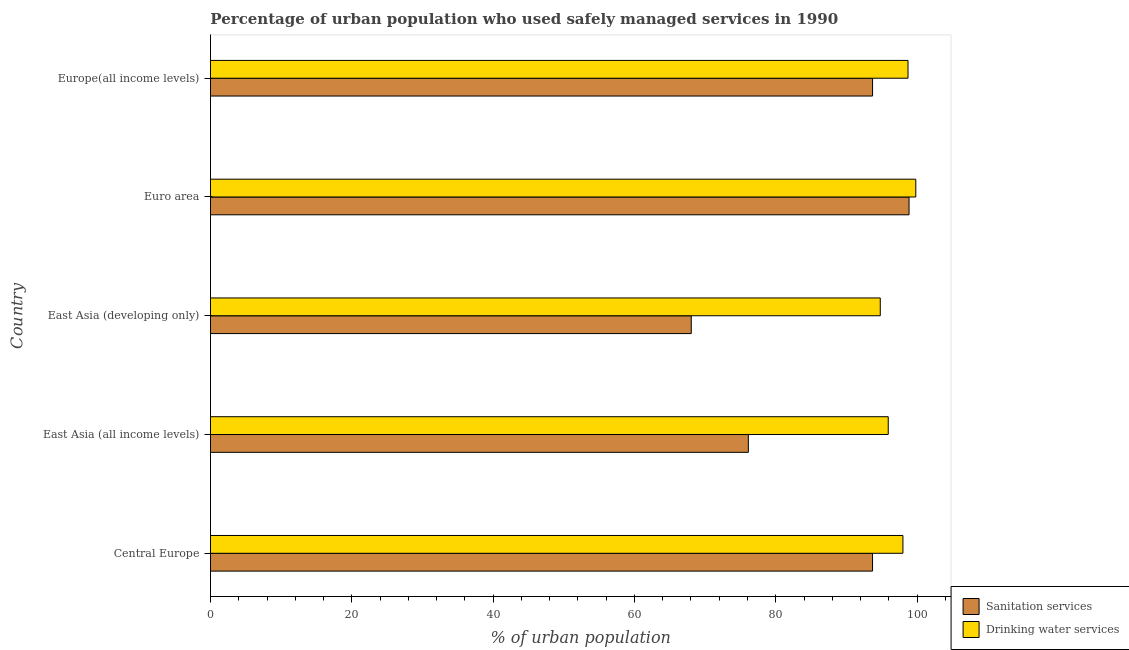Are the number of bars per tick equal to the number of legend labels?
Your answer should be very brief. Yes. Are the number of bars on each tick of the Y-axis equal?
Offer a terse response. Yes. What is the label of the 2nd group of bars from the top?
Offer a very short reply. Euro area. In how many cases, is the number of bars for a given country not equal to the number of legend labels?
Offer a very short reply. 0. What is the percentage of urban population who used drinking water services in Central Europe?
Offer a terse response. 97.99. Across all countries, what is the maximum percentage of urban population who used drinking water services?
Offer a terse response. 99.82. Across all countries, what is the minimum percentage of urban population who used drinking water services?
Offer a terse response. 94.79. In which country was the percentage of urban population who used sanitation services maximum?
Make the answer very short. Euro area. In which country was the percentage of urban population who used drinking water services minimum?
Your answer should be very brief. East Asia (developing only). What is the total percentage of urban population who used sanitation services in the graph?
Offer a terse response. 430.41. What is the difference between the percentage of urban population who used sanitation services in Euro area and that in Europe(all income levels)?
Your response must be concise. 5.16. What is the difference between the percentage of urban population who used sanitation services in East Asia (all income levels) and the percentage of urban population who used drinking water services in East Asia (developing only)?
Make the answer very short. -18.67. What is the average percentage of urban population who used drinking water services per country?
Your answer should be compact. 97.45. What is the difference between the percentage of urban population who used sanitation services and percentage of urban population who used drinking water services in East Asia (developing only)?
Provide a short and direct response. -26.75. What is the ratio of the percentage of urban population who used drinking water services in East Asia (developing only) to that in Europe(all income levels)?
Provide a succinct answer. 0.96. Is the difference between the percentage of urban population who used drinking water services in East Asia (all income levels) and East Asia (developing only) greater than the difference between the percentage of urban population who used sanitation services in East Asia (all income levels) and East Asia (developing only)?
Offer a terse response. No. What is the difference between the highest and the second highest percentage of urban population who used sanitation services?
Keep it short and to the point. 5.16. What is the difference between the highest and the lowest percentage of urban population who used drinking water services?
Provide a succinct answer. 5.03. Is the sum of the percentage of urban population who used sanitation services in Central Europe and Euro area greater than the maximum percentage of urban population who used drinking water services across all countries?
Give a very brief answer. Yes. What does the 2nd bar from the top in Euro area represents?
Your answer should be very brief. Sanitation services. What does the 2nd bar from the bottom in Euro area represents?
Make the answer very short. Drinking water services. How many countries are there in the graph?
Offer a very short reply. 5. What is the difference between two consecutive major ticks on the X-axis?
Make the answer very short. 20. Are the values on the major ticks of X-axis written in scientific E-notation?
Your response must be concise. No. Does the graph contain any zero values?
Offer a terse response. No. How many legend labels are there?
Ensure brevity in your answer.  2. How are the legend labels stacked?
Your answer should be very brief. Vertical. What is the title of the graph?
Keep it short and to the point. Percentage of urban population who used safely managed services in 1990. Does "Investment in Telecom" appear as one of the legend labels in the graph?
Provide a succinct answer. No. What is the label or title of the X-axis?
Your answer should be very brief. % of urban population. What is the % of urban population of Sanitation services in Central Europe?
Give a very brief answer. 93.69. What is the % of urban population of Drinking water services in Central Europe?
Your response must be concise. 97.99. What is the % of urban population of Sanitation services in East Asia (all income levels)?
Your answer should be very brief. 76.12. What is the % of urban population of Drinking water services in East Asia (all income levels)?
Offer a terse response. 95.92. What is the % of urban population in Sanitation services in East Asia (developing only)?
Make the answer very short. 68.04. What is the % of urban population of Drinking water services in East Asia (developing only)?
Ensure brevity in your answer.  94.79. What is the % of urban population in Sanitation services in Euro area?
Make the answer very short. 98.86. What is the % of urban population of Drinking water services in Euro area?
Make the answer very short. 99.82. What is the % of urban population of Sanitation services in Europe(all income levels)?
Offer a terse response. 93.7. What is the % of urban population of Drinking water services in Europe(all income levels)?
Provide a succinct answer. 98.71. Across all countries, what is the maximum % of urban population in Sanitation services?
Offer a very short reply. 98.86. Across all countries, what is the maximum % of urban population in Drinking water services?
Your answer should be compact. 99.82. Across all countries, what is the minimum % of urban population in Sanitation services?
Make the answer very short. 68.04. Across all countries, what is the minimum % of urban population of Drinking water services?
Ensure brevity in your answer.  94.79. What is the total % of urban population in Sanitation services in the graph?
Your answer should be compact. 430.41. What is the total % of urban population in Drinking water services in the graph?
Ensure brevity in your answer.  487.23. What is the difference between the % of urban population in Sanitation services in Central Europe and that in East Asia (all income levels)?
Ensure brevity in your answer.  17.58. What is the difference between the % of urban population in Drinking water services in Central Europe and that in East Asia (all income levels)?
Provide a succinct answer. 2.08. What is the difference between the % of urban population in Sanitation services in Central Europe and that in East Asia (developing only)?
Ensure brevity in your answer.  25.65. What is the difference between the % of urban population in Drinking water services in Central Europe and that in East Asia (developing only)?
Ensure brevity in your answer.  3.21. What is the difference between the % of urban population of Sanitation services in Central Europe and that in Euro area?
Provide a succinct answer. -5.17. What is the difference between the % of urban population of Drinking water services in Central Europe and that in Euro area?
Provide a succinct answer. -1.82. What is the difference between the % of urban population in Sanitation services in Central Europe and that in Europe(all income levels)?
Provide a succinct answer. -0. What is the difference between the % of urban population in Drinking water services in Central Europe and that in Europe(all income levels)?
Offer a very short reply. -0.72. What is the difference between the % of urban population of Sanitation services in East Asia (all income levels) and that in East Asia (developing only)?
Provide a short and direct response. 8.08. What is the difference between the % of urban population of Drinking water services in East Asia (all income levels) and that in East Asia (developing only)?
Your answer should be very brief. 1.13. What is the difference between the % of urban population of Sanitation services in East Asia (all income levels) and that in Euro area?
Provide a succinct answer. -22.74. What is the difference between the % of urban population of Drinking water services in East Asia (all income levels) and that in Euro area?
Make the answer very short. -3.9. What is the difference between the % of urban population in Sanitation services in East Asia (all income levels) and that in Europe(all income levels)?
Provide a short and direct response. -17.58. What is the difference between the % of urban population in Drinking water services in East Asia (all income levels) and that in Europe(all income levels)?
Your answer should be compact. -2.8. What is the difference between the % of urban population in Sanitation services in East Asia (developing only) and that in Euro area?
Make the answer very short. -30.82. What is the difference between the % of urban population of Drinking water services in East Asia (developing only) and that in Euro area?
Offer a very short reply. -5.03. What is the difference between the % of urban population in Sanitation services in East Asia (developing only) and that in Europe(all income levels)?
Provide a short and direct response. -25.66. What is the difference between the % of urban population of Drinking water services in East Asia (developing only) and that in Europe(all income levels)?
Provide a succinct answer. -3.93. What is the difference between the % of urban population in Sanitation services in Euro area and that in Europe(all income levels)?
Keep it short and to the point. 5.16. What is the difference between the % of urban population of Drinking water services in Euro area and that in Europe(all income levels)?
Your answer should be compact. 1.1. What is the difference between the % of urban population in Sanitation services in Central Europe and the % of urban population in Drinking water services in East Asia (all income levels)?
Ensure brevity in your answer.  -2.22. What is the difference between the % of urban population in Sanitation services in Central Europe and the % of urban population in Drinking water services in East Asia (developing only)?
Your answer should be compact. -1.09. What is the difference between the % of urban population of Sanitation services in Central Europe and the % of urban population of Drinking water services in Euro area?
Offer a very short reply. -6.12. What is the difference between the % of urban population of Sanitation services in Central Europe and the % of urban population of Drinking water services in Europe(all income levels)?
Your answer should be very brief. -5.02. What is the difference between the % of urban population of Sanitation services in East Asia (all income levels) and the % of urban population of Drinking water services in East Asia (developing only)?
Ensure brevity in your answer.  -18.67. What is the difference between the % of urban population of Sanitation services in East Asia (all income levels) and the % of urban population of Drinking water services in Euro area?
Provide a short and direct response. -23.7. What is the difference between the % of urban population of Sanitation services in East Asia (all income levels) and the % of urban population of Drinking water services in Europe(all income levels)?
Provide a short and direct response. -22.6. What is the difference between the % of urban population of Sanitation services in East Asia (developing only) and the % of urban population of Drinking water services in Euro area?
Keep it short and to the point. -31.78. What is the difference between the % of urban population of Sanitation services in East Asia (developing only) and the % of urban population of Drinking water services in Europe(all income levels)?
Your answer should be compact. -30.67. What is the difference between the % of urban population in Sanitation services in Euro area and the % of urban population in Drinking water services in Europe(all income levels)?
Your answer should be compact. 0.15. What is the average % of urban population of Sanitation services per country?
Keep it short and to the point. 86.08. What is the average % of urban population in Drinking water services per country?
Your answer should be very brief. 97.45. What is the difference between the % of urban population in Sanitation services and % of urban population in Drinking water services in Central Europe?
Your answer should be very brief. -4.3. What is the difference between the % of urban population in Sanitation services and % of urban population in Drinking water services in East Asia (all income levels)?
Offer a very short reply. -19.8. What is the difference between the % of urban population in Sanitation services and % of urban population in Drinking water services in East Asia (developing only)?
Ensure brevity in your answer.  -26.75. What is the difference between the % of urban population of Sanitation services and % of urban population of Drinking water services in Euro area?
Your answer should be compact. -0.96. What is the difference between the % of urban population of Sanitation services and % of urban population of Drinking water services in Europe(all income levels)?
Make the answer very short. -5.02. What is the ratio of the % of urban population in Sanitation services in Central Europe to that in East Asia (all income levels)?
Provide a short and direct response. 1.23. What is the ratio of the % of urban population of Drinking water services in Central Europe to that in East Asia (all income levels)?
Give a very brief answer. 1.02. What is the ratio of the % of urban population in Sanitation services in Central Europe to that in East Asia (developing only)?
Provide a short and direct response. 1.38. What is the ratio of the % of urban population of Drinking water services in Central Europe to that in East Asia (developing only)?
Your response must be concise. 1.03. What is the ratio of the % of urban population in Sanitation services in Central Europe to that in Euro area?
Provide a short and direct response. 0.95. What is the ratio of the % of urban population of Drinking water services in Central Europe to that in Euro area?
Offer a terse response. 0.98. What is the ratio of the % of urban population of Sanitation services in East Asia (all income levels) to that in East Asia (developing only)?
Ensure brevity in your answer.  1.12. What is the ratio of the % of urban population of Drinking water services in East Asia (all income levels) to that in East Asia (developing only)?
Make the answer very short. 1.01. What is the ratio of the % of urban population in Sanitation services in East Asia (all income levels) to that in Euro area?
Your answer should be very brief. 0.77. What is the ratio of the % of urban population in Drinking water services in East Asia (all income levels) to that in Euro area?
Your response must be concise. 0.96. What is the ratio of the % of urban population of Sanitation services in East Asia (all income levels) to that in Europe(all income levels)?
Your response must be concise. 0.81. What is the ratio of the % of urban population in Drinking water services in East Asia (all income levels) to that in Europe(all income levels)?
Make the answer very short. 0.97. What is the ratio of the % of urban population in Sanitation services in East Asia (developing only) to that in Euro area?
Give a very brief answer. 0.69. What is the ratio of the % of urban population in Drinking water services in East Asia (developing only) to that in Euro area?
Offer a terse response. 0.95. What is the ratio of the % of urban population of Sanitation services in East Asia (developing only) to that in Europe(all income levels)?
Ensure brevity in your answer.  0.73. What is the ratio of the % of urban population in Drinking water services in East Asia (developing only) to that in Europe(all income levels)?
Keep it short and to the point. 0.96. What is the ratio of the % of urban population in Sanitation services in Euro area to that in Europe(all income levels)?
Your answer should be compact. 1.06. What is the ratio of the % of urban population in Drinking water services in Euro area to that in Europe(all income levels)?
Provide a succinct answer. 1.01. What is the difference between the highest and the second highest % of urban population of Sanitation services?
Offer a terse response. 5.16. What is the difference between the highest and the second highest % of urban population of Drinking water services?
Your answer should be compact. 1.1. What is the difference between the highest and the lowest % of urban population in Sanitation services?
Make the answer very short. 30.82. What is the difference between the highest and the lowest % of urban population in Drinking water services?
Provide a short and direct response. 5.03. 